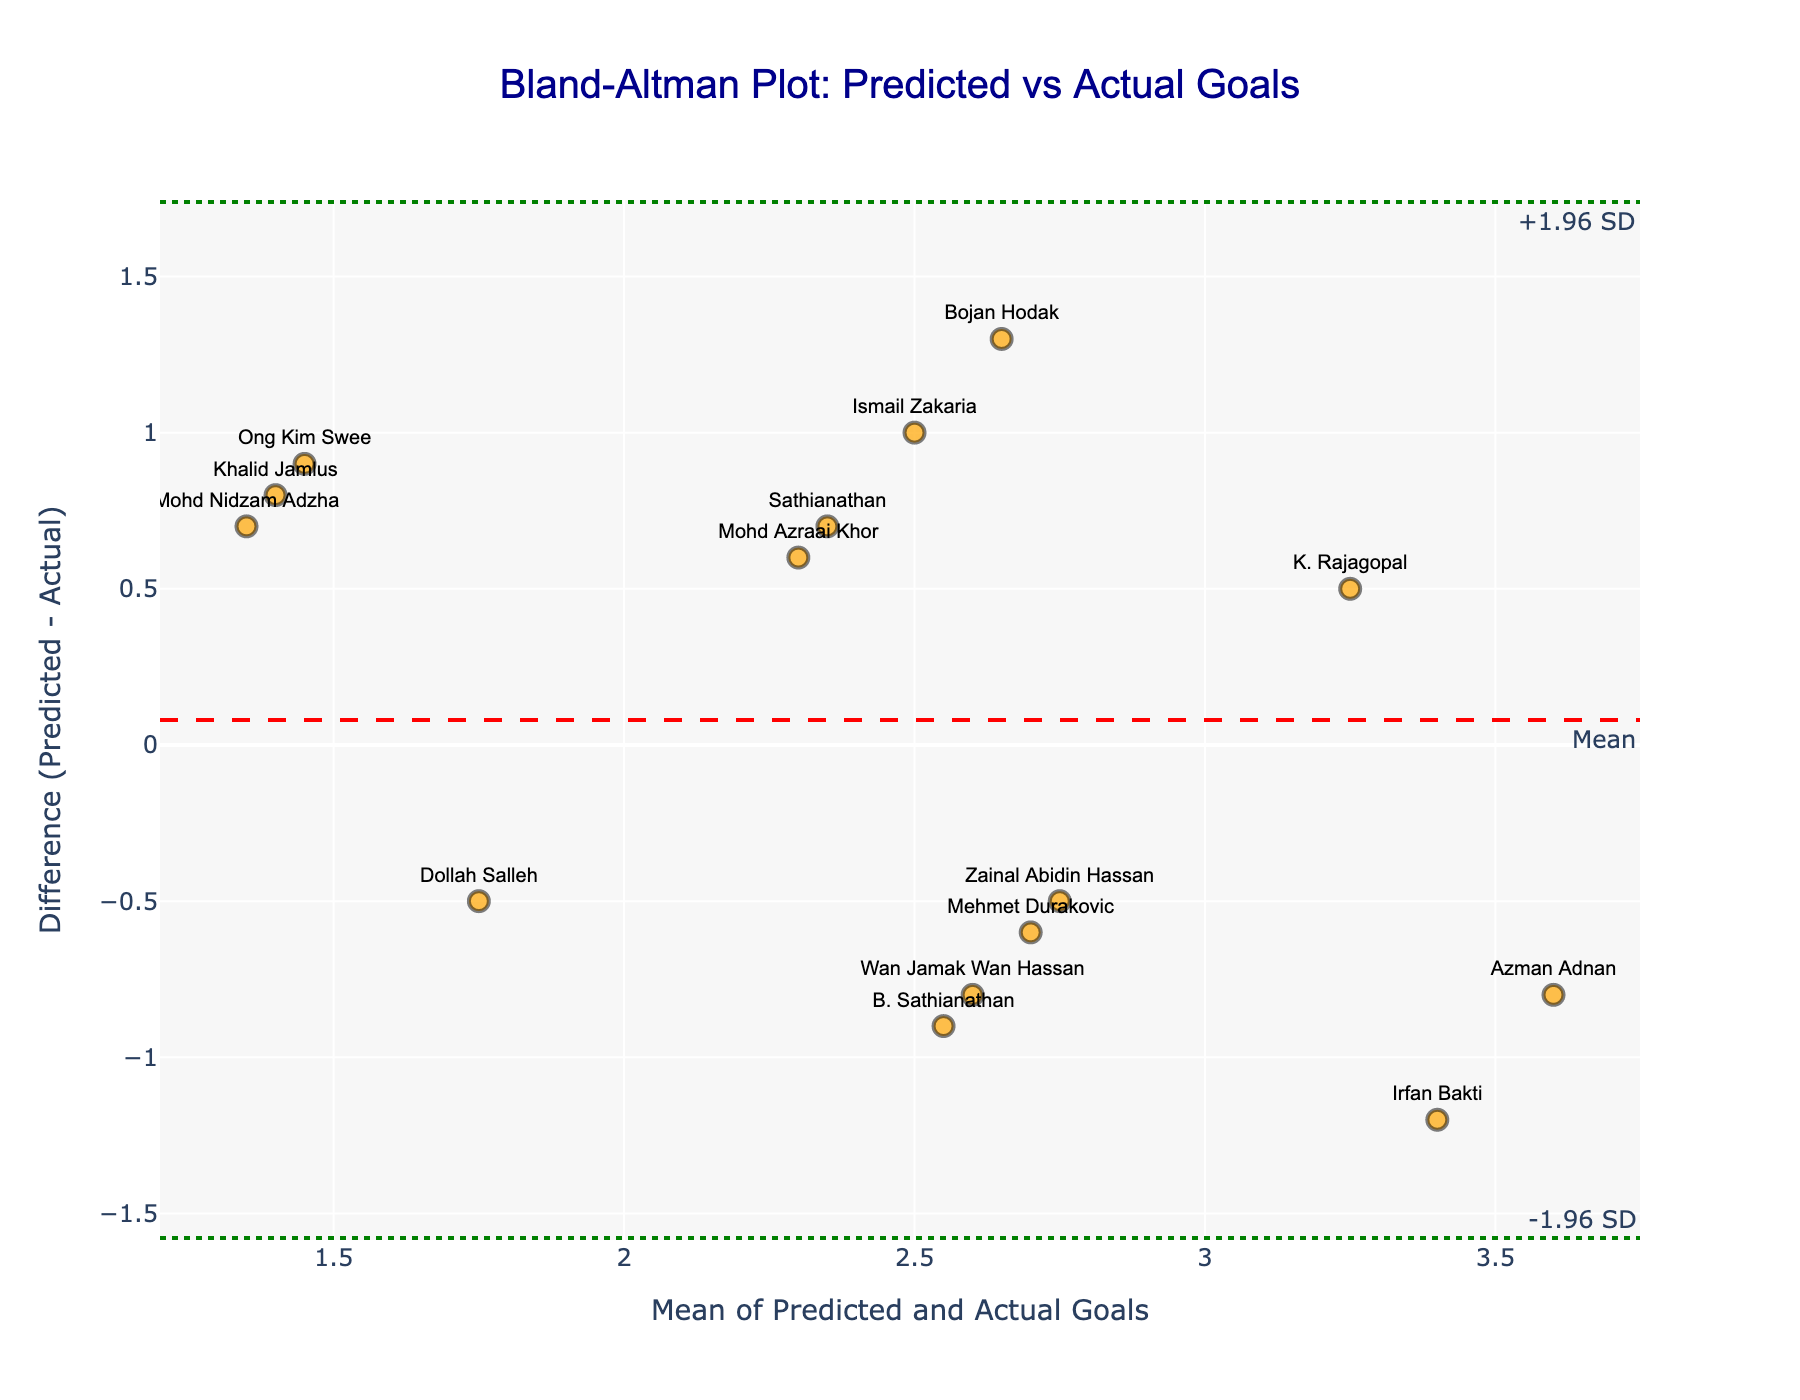How many analysts are represented in the plot? To count the number of analysts, just count the number of data points (markers) in the plot, as each marker represents an analyst's predictions versus actual goals.
Answer: 15 What is the title of the plot? The title of the plot is given in the layout section, appearing at the top of the plot in a larger font.
Answer: Bland-Altman Plot: Predicted vs Actual Goals What does the red dashed line represent? The red dashed line in a Bland-Altman plot represents the mean difference between the predicted goals and the actual goals.
Answer: Mean difference Which analyst had the largest positive difference between predicted and actual goals? To find the largest positive difference, look for the highest point above the zero line on the y-axis. The associated text label next to the data point will show the analyst's name.
Answer: Bojan Hodak What does the green dotted line above the red dashed line represent? The green dotted line above the red dashed line in a Bland-Altman plot represents the mean difference plus 1.96 times the standard deviation of the differences.
Answer: +1.96 SD What is the mean of the predicted and actual goals for Sathianathan? Locate the data point labeled "Sathianathan" and note the x-axis value, which represents the mean of the predicted and actual goals for that analyst.
Answer: 2.35 On average, did analysts overestimate or underestimate the goals? Check the red dashed line position relative to the zero line on the y-axis. If it is above zero, they overestimated; if below zero, they underestimated.
Answer: Underestimated How many analysts predicted exactly the same number of goals as the actual outcome? Look for data points that lie on the zero line on the y-axis, as these represent a zero difference between predicted and actual goals.
Answer: 2 What is the approximate range of the differences between predicted and actual goals? Determine the maximum and minimum values on the y-axis where the data points spread, noting the range of differences between predicted and actual goals.
Answer: -1.5 to 1.3 Which analyst predicted the closest to the actual goals for their match? Look for the data point closest to the zero value on the y-axis, as this shows the smallest difference between predicted and actual goals. The associated label next to the point gives the analyst's name.
Answer: Ong Kim Swee 